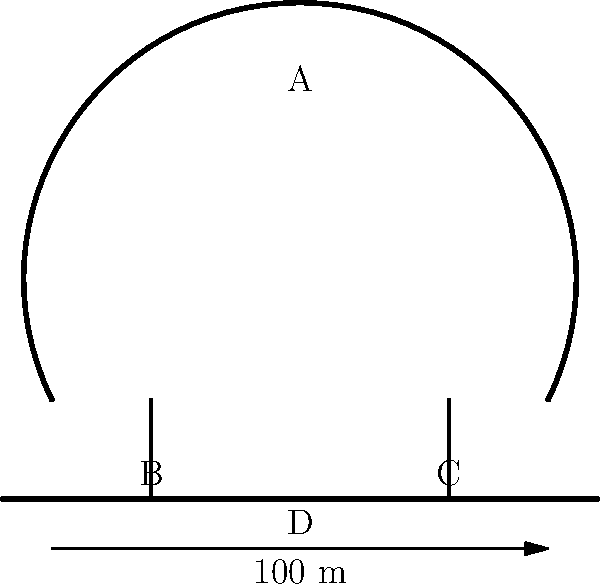The diagram shows a simplified schematic representation of the Sydney Opera House's main shell structure. If the base (D) is 100 meters wide, approximately how tall is the highest point of the shell (A) from the base? To estimate the height of the Sydney Opera House's main shell structure, we can follow these steps:

1. Observe the diagram: The structure is represented as a curved shell supported by two pillars on a base.

2. Identify the given information: The base (D) is 100 meters wide.

3. Estimate the height-to-width ratio: In the diagram, the height of the shell appears to be about 80% of its width.

4. Calculate the approximate height:
   - Width of the base = 100 meters
   - Estimated height = 80% of the width
   - Height ≈ 100 m × 0.8 = 80 meters

5. Round the result: Since this is an approximation based on a simplified diagram, it's appropriate to round to the nearest 5 meters.

Therefore, the highest point of the shell (A) is approximately 80 meters above the base.

Note: The actual Sydney Opera House's highest point is about 67 meters, but this estimation is based solely on the given schematic representation.
Answer: 80 meters 